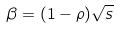Convert formula to latex. <formula><loc_0><loc_0><loc_500><loc_500>\beta = ( 1 - \rho ) \sqrt { s }</formula> 